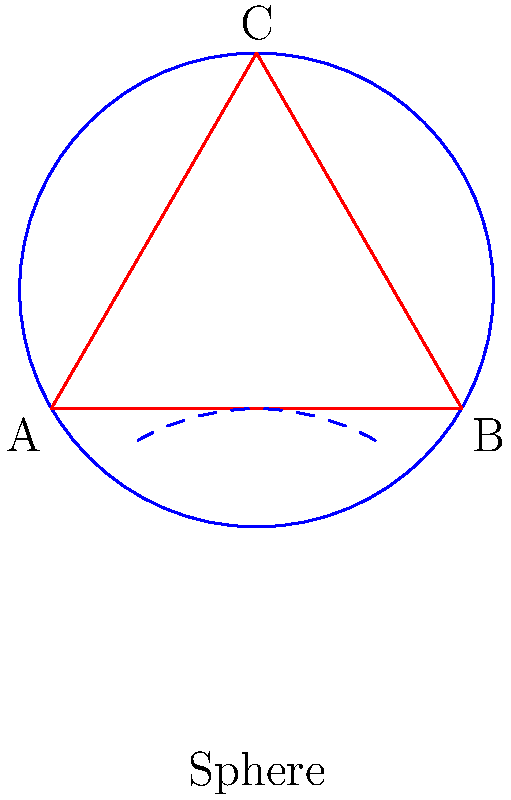As a journalist investigating the implications of non-Euclidean geometry on our understanding of space, you come across a peculiar property of triangles on a sphere. In the diagram, a triangle ABC is drawn on the surface of a sphere. How does the sum of the interior angles of this spherical triangle compare to that of a planar triangle, and what does this reveal about the curvature of space? To understand this concept, let's break it down step by step:

1. In Euclidean (planar) geometry, the sum of interior angles of a triangle is always 180°.

2. On a sphere, however, the geometry is non-Euclidean due to its curved surface.

3. The lines of the triangle on a sphere are actually great circles, which are the largest circles that can be drawn on the sphere's surface.

4. As these great circles curve with the sphere's surface, they create "fatter" triangles than would exist on a flat plane.

5. This curvature causes the interior angles of the spherical triangle to be larger than they would be in a planar triangle with the same side lengths.

6. The sum of the interior angles of a spherical triangle is always greater than 180°.

7. The exact sum depends on the size of the triangle relative to the sphere's surface area. Larger triangles (covering more of the sphere's surface) have a greater sum of interior angles.

8. The difference between the sum of the angles and 180° is called the "spherical excess" (E). It's proportional to the area of the triangle on the sphere.

9. The formula for spherical excess is: $E = A/R^2$, where A is the area of the triangle and R is the radius of the sphere.

10. This property reveals that space on a sphere has positive curvature. Positive curvature is characterized by the sum of angles in a triangle being greater than 180°.

This concept is crucial in understanding the nature of curved spaces and has implications for our understanding of the universe in general relativity, where space itself can be curved by massive objects.
Answer: The sum of interior angles > 180°, indicating positive curvature of space on a sphere. 